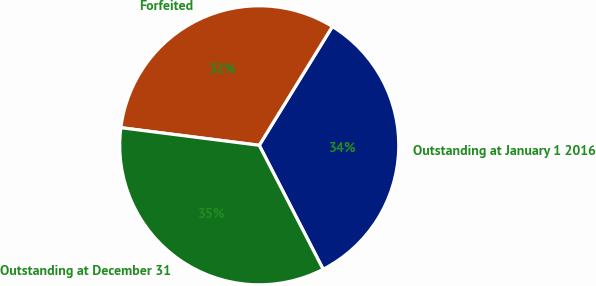Convert chart to OTSL. <chart><loc_0><loc_0><loc_500><loc_500><pie_chart><fcel>Outstanding at January 1 2016<fcel>Forfeited<fcel>Outstanding at December 31<nl><fcel>33.64%<fcel>31.77%<fcel>34.59%<nl></chart> 